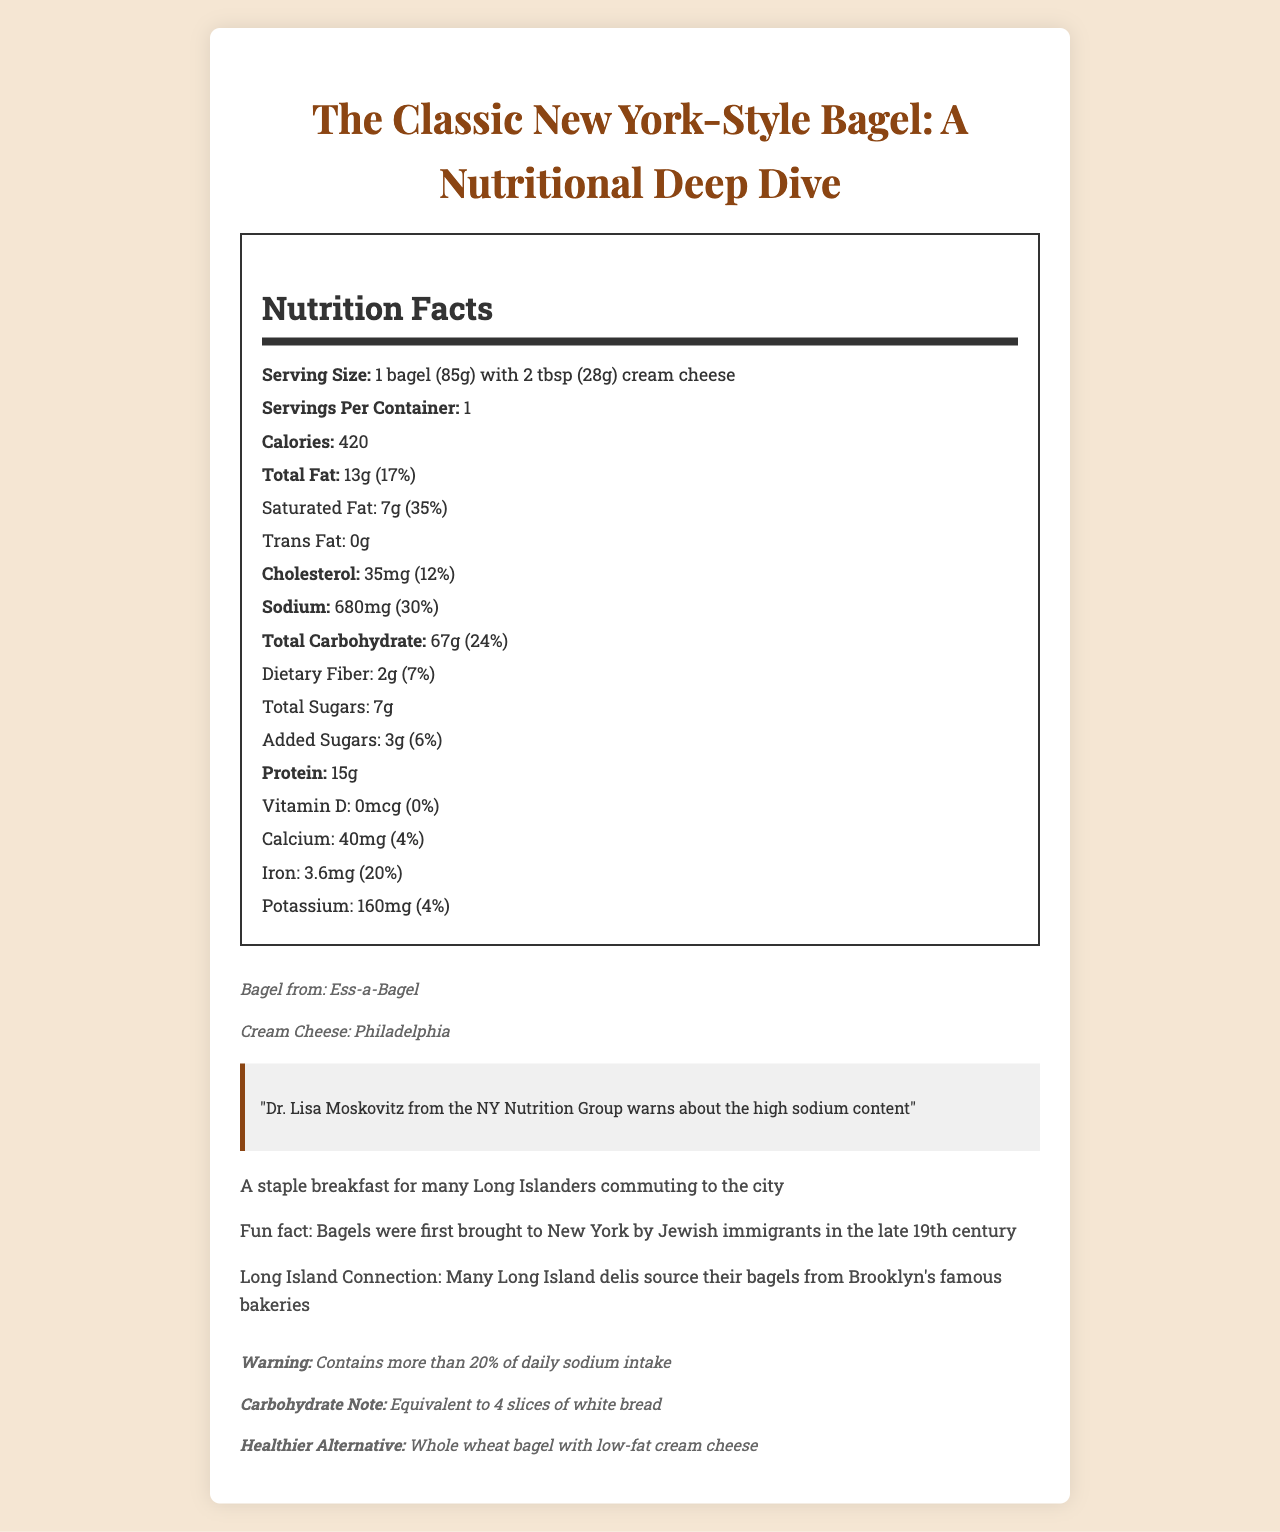what is the serving size for a single bagel with cream cheese? The serving size is clearly listed at the top of the Nutrition Facts section in the document.
Answer: 1 bagel (85g) with 2 tbsp (28g) cream cheese how many calories does one serving contain? The calorie count is listed after the serving size and servings per container in the Nutrition Facts section.
Answer: 420 what is the amount of sodium in one serving? The sodium amount is provided in the Nutrition Facts under the section labeled "Sodium."
Answer: 680 mg how much total carbohydrate does one serving have? The total carbohydrate content is listed under the "Total Carbohydrate" section in the Nutrition Facts.
Answer: 67 g what percentage of the daily value for sodium does one serving represent? The daily value percentage for sodium is provided next to the sodium amount.
Answer: 30% what brand of cream cheese is used? This information is found in the extra-info section below the Nutrition Facts.
Answer: Philadelphia who provided the nutritionist quote in the document? This detail is mentioned in the quote section in the document.
Answer: Dr. Lisa Moskovitz from the NY Nutrition Group what is equivalent to the carbohydrate content of one serving of the bagel with cream cheese? This note is found in the additional information section under "Carbohydrate Note."
Answer: Equivalent to 4 slices of white bread which local bakery is compared to Ess-a-Bagel in the document? A. Bagel Boss B. Brooklyn Bagels C. Bagel Express The comparison is made in the additional information section under "localComparisonBagel."
Answer: A. Bagel Boss what are some popular toppings mentioned for the bagel? A. Lox B. Capers C. Red Onion D. Peanut Butter Popular toppings listed include Lox, Capers, and Red Onion but not Peanut Butter.
Answer: I, II, III does one serving contain any trans fat? The amount of trans fat is listed as 0 g in the Nutrition Facts.
Answer: No summarize the main idea of this document. The document presents the nutritional content along with relevant contextual information like local comparisons, historical facts, and expert opinions to give a comprehensive view.
Answer: The document provides a detailed Nutrition Facts label for a traditional New York-style bagel with cream cheese, focusing on its carbohydrate and sodium levels. It includes additional local and historical notes, as well as a nutritionist's warning about the high sodium content. how much Vitamin D is in one serving? The amount of Vitamin D is listed in the Nutrition Facts section, showing a value of 0 mcg.
Answer: 0 mcg which nutrient does the bagel with cream cheese provide the highest daily value percentage for? Saturated fat has the highest daily value percentage listed in the Nutritional Facts.
Answer: Saturated Fat, 35% what is the total protein content in one serving? According to the Nutrition Facts, the total protein content for one serving is 15 grams.
Answer: 15 g how much added sugar is in one serving? The Nutrition Facts section indicates that there are 3 grams of added sugar per serving.
Answer: 3 g what is the Long Island connection regarding the bagels? This information is detailed in the additional information section under "Long Island Connection."
Answer: Many Long Island delis source their bagels from Brooklyn's famous bakeries which bakery provided the bagel in the nutritional analysis? This detail is listed under the extra-info section, noting the origin of the analyzed bagel.
Answer: Ess-a-Bagel who originally brought bagels to New York? The historical fact about bagels being brought to New York is found in the additional information section.
Answer: Jewish immigrants in the late 19th century what is the healthier alternative suggested for this bagel option? The healthier alternative is listed in the additional information section under "healthyAlternative."
Answer: Whole wheat bagel with low-fat cream cheese can we determine the total amount of calcium in the document? The total amount of calcium is listed in the Nutrition Facts as 40 mg.
Answer: Yes, 40 mg does the document provide information about the fiber content? The Nutrition Facts section lists the dietary fiber content, showing an amount of 2 grams.
Answer: Yes 